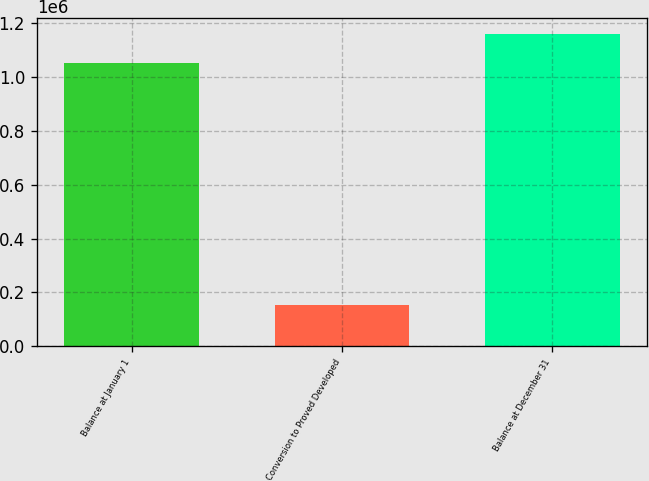Convert chart to OTSL. <chart><loc_0><loc_0><loc_500><loc_500><bar_chart><fcel>Balance at January 1<fcel>Conversion to Proved Developed<fcel>Balance at December 31<nl><fcel>1.05303e+06<fcel>152644<fcel>1.16264e+06<nl></chart> 